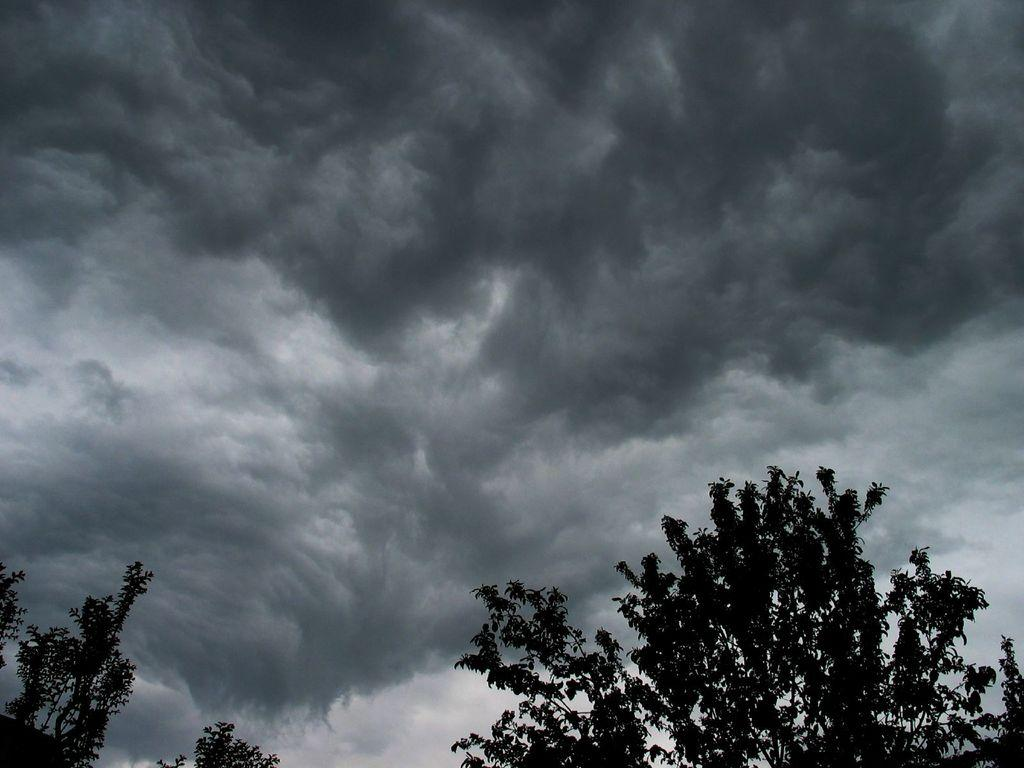What type of vegetation is at the bottom of the image? There are trees at the bottom of the image. What is the condition of the sky in the sky in the image? The sky is cloudy in the image. What type of root can be seen growing from the trees in the image? There is no root visible in the image; only the trees themselves are present. What season is depicted in the image? The provided facts do not mention a specific season, so it cannot be determined from the image. 